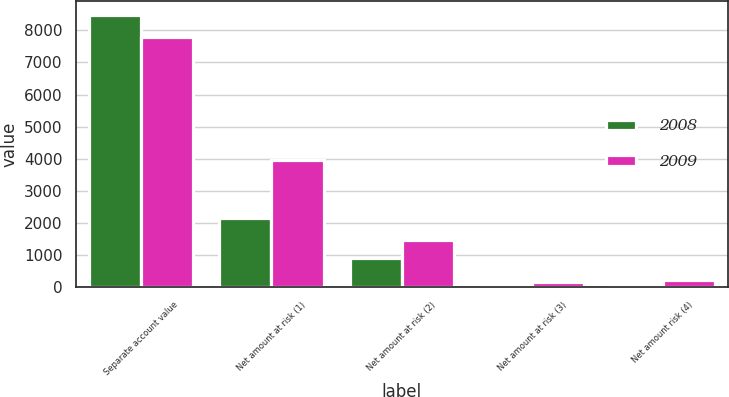Convert chart to OTSL. <chart><loc_0><loc_0><loc_500><loc_500><stacked_bar_chart><ecel><fcel>Separate account value<fcel>Net amount at risk (1)<fcel>Net amount at risk (2)<fcel>Net amount at risk (3)<fcel>Net amount risk (4)<nl><fcel>2008<fcel>8496<fcel>2153<fcel>906<fcel>42<fcel>97<nl><fcel>2009<fcel>7802<fcel>3971<fcel>1459<fcel>159<fcel>223<nl></chart> 